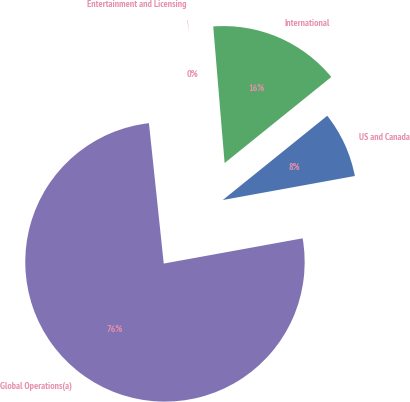Convert chart to OTSL. <chart><loc_0><loc_0><loc_500><loc_500><pie_chart><fcel>US and Canada<fcel>International<fcel>Entertainment and Licensing<fcel>Global Operations(a)<nl><fcel>7.94%<fcel>15.52%<fcel>0.35%<fcel>76.19%<nl></chart> 